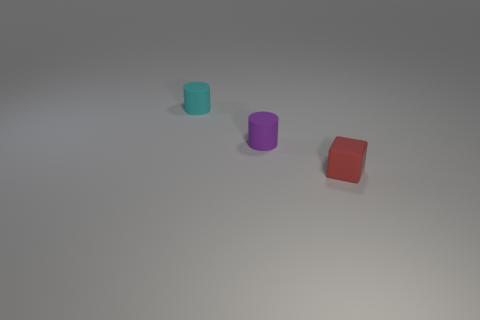The red object in front of the object to the left of the rubber cylinder that is on the right side of the tiny cyan rubber object is what shape?
Ensure brevity in your answer.  Cube. The rubber object that is right of the small cyan object and behind the red thing is what color?
Provide a short and direct response. Purple. What is the shape of the thing behind the tiny purple thing?
Give a very brief answer. Cylinder. What shape is the small cyan object that is the same material as the red thing?
Your response must be concise. Cylinder. How many shiny objects are either cylinders or purple objects?
Your answer should be very brief. 0. What number of tiny matte cylinders are in front of the tiny rubber object behind the small rubber cylinder that is in front of the cyan thing?
Offer a very short reply. 1. There is a cylinder that is in front of the small cyan cylinder; is it the same size as the rubber object in front of the small purple object?
Offer a terse response. Yes. What number of tiny things are either red metal objects or matte cubes?
Your answer should be compact. 1. What is the material of the red thing that is the same size as the purple matte cylinder?
Your answer should be compact. Rubber. Are there any tiny balls that have the same material as the small cyan object?
Keep it short and to the point. No. 